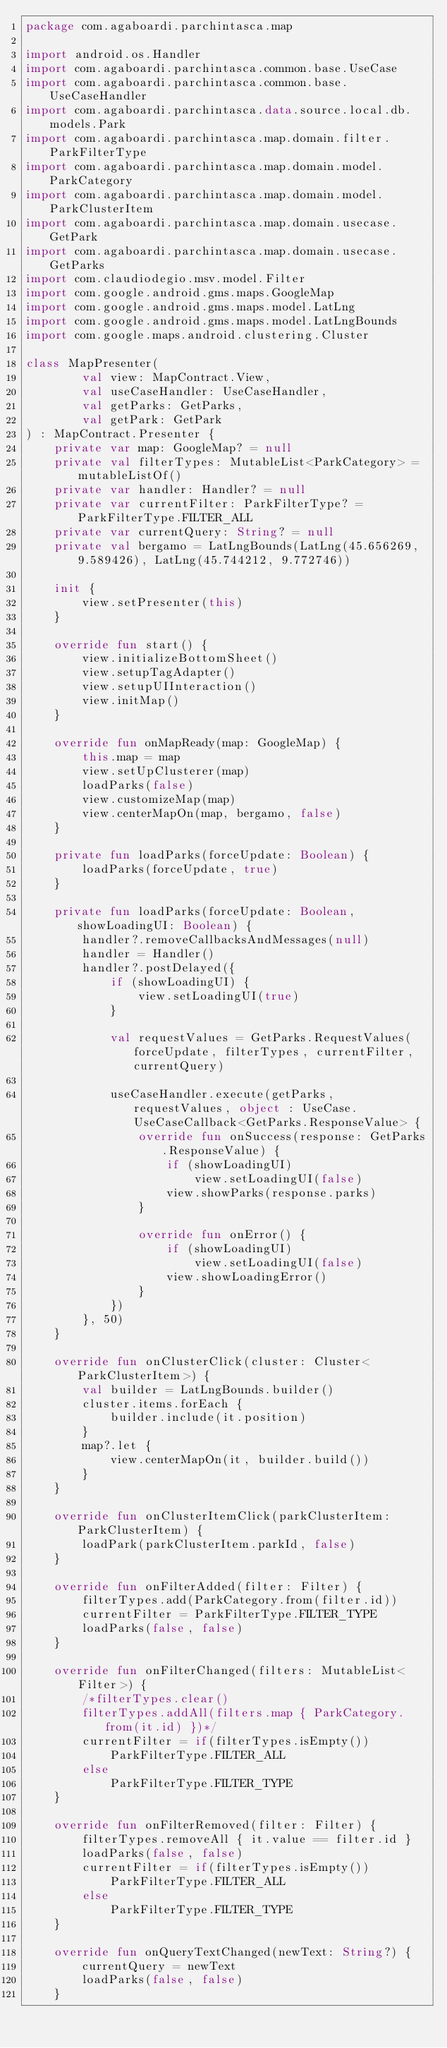<code> <loc_0><loc_0><loc_500><loc_500><_Kotlin_>package com.agaboardi.parchintasca.map

import android.os.Handler
import com.agaboardi.parchintasca.common.base.UseCase
import com.agaboardi.parchintasca.common.base.UseCaseHandler
import com.agaboardi.parchintasca.data.source.local.db.models.Park
import com.agaboardi.parchintasca.map.domain.filter.ParkFilterType
import com.agaboardi.parchintasca.map.domain.model.ParkCategory
import com.agaboardi.parchintasca.map.domain.model.ParkClusterItem
import com.agaboardi.parchintasca.map.domain.usecase.GetPark
import com.agaboardi.parchintasca.map.domain.usecase.GetParks
import com.claudiodegio.msv.model.Filter
import com.google.android.gms.maps.GoogleMap
import com.google.android.gms.maps.model.LatLng
import com.google.android.gms.maps.model.LatLngBounds
import com.google.maps.android.clustering.Cluster

class MapPresenter(
        val view: MapContract.View,
        val useCaseHandler: UseCaseHandler,
        val getParks: GetParks,
        val getPark: GetPark
) : MapContract.Presenter {
    private var map: GoogleMap? = null
    private val filterTypes: MutableList<ParkCategory> = mutableListOf()
    private var handler: Handler? = null
    private var currentFilter: ParkFilterType? = ParkFilterType.FILTER_ALL
    private var currentQuery: String? = null
    private val bergamo = LatLngBounds(LatLng(45.656269, 9.589426), LatLng(45.744212, 9.772746))

    init {
        view.setPresenter(this)
    }

    override fun start() {
        view.initializeBottomSheet()
        view.setupTagAdapter()
        view.setupUIInteraction()
        view.initMap()
    }

    override fun onMapReady(map: GoogleMap) {
        this.map = map
        view.setUpClusterer(map)
        loadParks(false)
        view.customizeMap(map)
        view.centerMapOn(map, bergamo, false)
    }

    private fun loadParks(forceUpdate: Boolean) {
        loadParks(forceUpdate, true)
    }

    private fun loadParks(forceUpdate: Boolean, showLoadingUI: Boolean) {
        handler?.removeCallbacksAndMessages(null)
        handler = Handler()
        handler?.postDelayed({
            if (showLoadingUI) {
                view.setLoadingUI(true)
            }

            val requestValues = GetParks.RequestValues(forceUpdate, filterTypes, currentFilter, currentQuery)

            useCaseHandler.execute(getParks, requestValues, object : UseCase.UseCaseCallback<GetParks.ResponseValue> {
                override fun onSuccess(response: GetParks.ResponseValue) {
                    if (showLoadingUI)
                        view.setLoadingUI(false)
                    view.showParks(response.parks)
                }

                override fun onError() {
                    if (showLoadingUI)
                        view.setLoadingUI(false)
                    view.showLoadingError()
                }
            })
        }, 50)
    }

    override fun onClusterClick(cluster: Cluster<ParkClusterItem>) {
        val builder = LatLngBounds.builder()
        cluster.items.forEach {
            builder.include(it.position)
        }
        map?.let {
            view.centerMapOn(it, builder.build())
        }
    }

    override fun onClusterItemClick(parkClusterItem: ParkClusterItem) {
        loadPark(parkClusterItem.parkId, false)
    }

    override fun onFilterAdded(filter: Filter) {
        filterTypes.add(ParkCategory.from(filter.id))
        currentFilter = ParkFilterType.FILTER_TYPE
        loadParks(false, false)
    }

    override fun onFilterChanged(filters: MutableList<Filter>) {
        /*filterTypes.clear()
        filterTypes.addAll(filters.map { ParkCategory.from(it.id) })*/
        currentFilter = if(filterTypes.isEmpty())
            ParkFilterType.FILTER_ALL
        else
            ParkFilterType.FILTER_TYPE
    }

    override fun onFilterRemoved(filter: Filter) {
        filterTypes.removeAll { it.value == filter.id }
        loadParks(false, false)
        currentFilter = if(filterTypes.isEmpty())
            ParkFilterType.FILTER_ALL
        else
            ParkFilterType.FILTER_TYPE
    }

    override fun onQueryTextChanged(newText: String?) {
        currentQuery = newText
        loadParks(false, false)
    }
</code> 